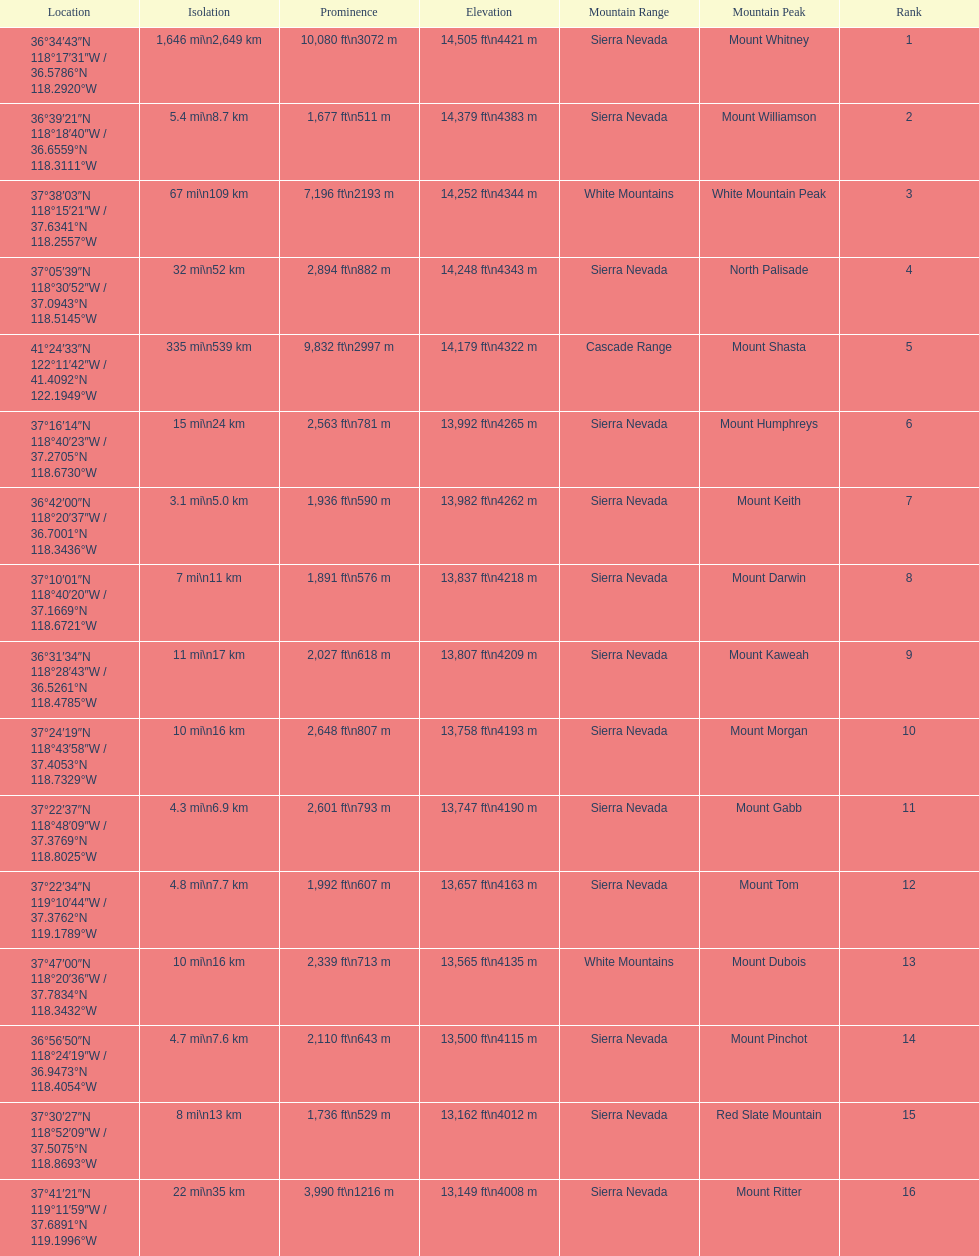What are the peaks in california? Mount Whitney, Mount Williamson, White Mountain Peak, North Palisade, Mount Shasta, Mount Humphreys, Mount Keith, Mount Darwin, Mount Kaweah, Mount Morgan, Mount Gabb, Mount Tom, Mount Dubois, Mount Pinchot, Red Slate Mountain, Mount Ritter. What are the peaks in sierra nevada, california? Mount Whitney, Mount Williamson, North Palisade, Mount Humphreys, Mount Keith, Mount Darwin, Mount Kaweah, Mount Morgan, Mount Gabb, Mount Tom, Mount Pinchot, Red Slate Mountain, Mount Ritter. What are the heights of the peaks in sierra nevada? 14,505 ft\n4421 m, 14,379 ft\n4383 m, 14,248 ft\n4343 m, 13,992 ft\n4265 m, 13,982 ft\n4262 m, 13,837 ft\n4218 m, 13,807 ft\n4209 m, 13,758 ft\n4193 m, 13,747 ft\n4190 m, 13,657 ft\n4163 m, 13,500 ft\n4115 m, 13,162 ft\n4012 m, 13,149 ft\n4008 m. Which is the highest? Mount Whitney. 